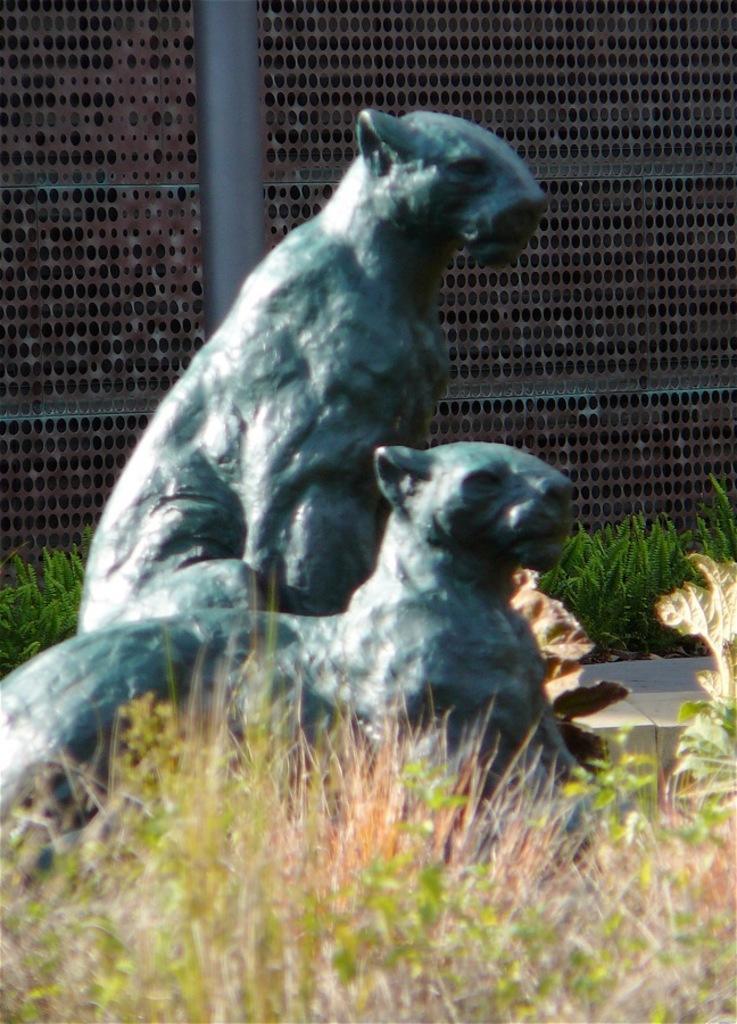Could you give a brief overview of what you see in this image? Here we can see a grass and statues. Background there is a pole, plants and mesh. 